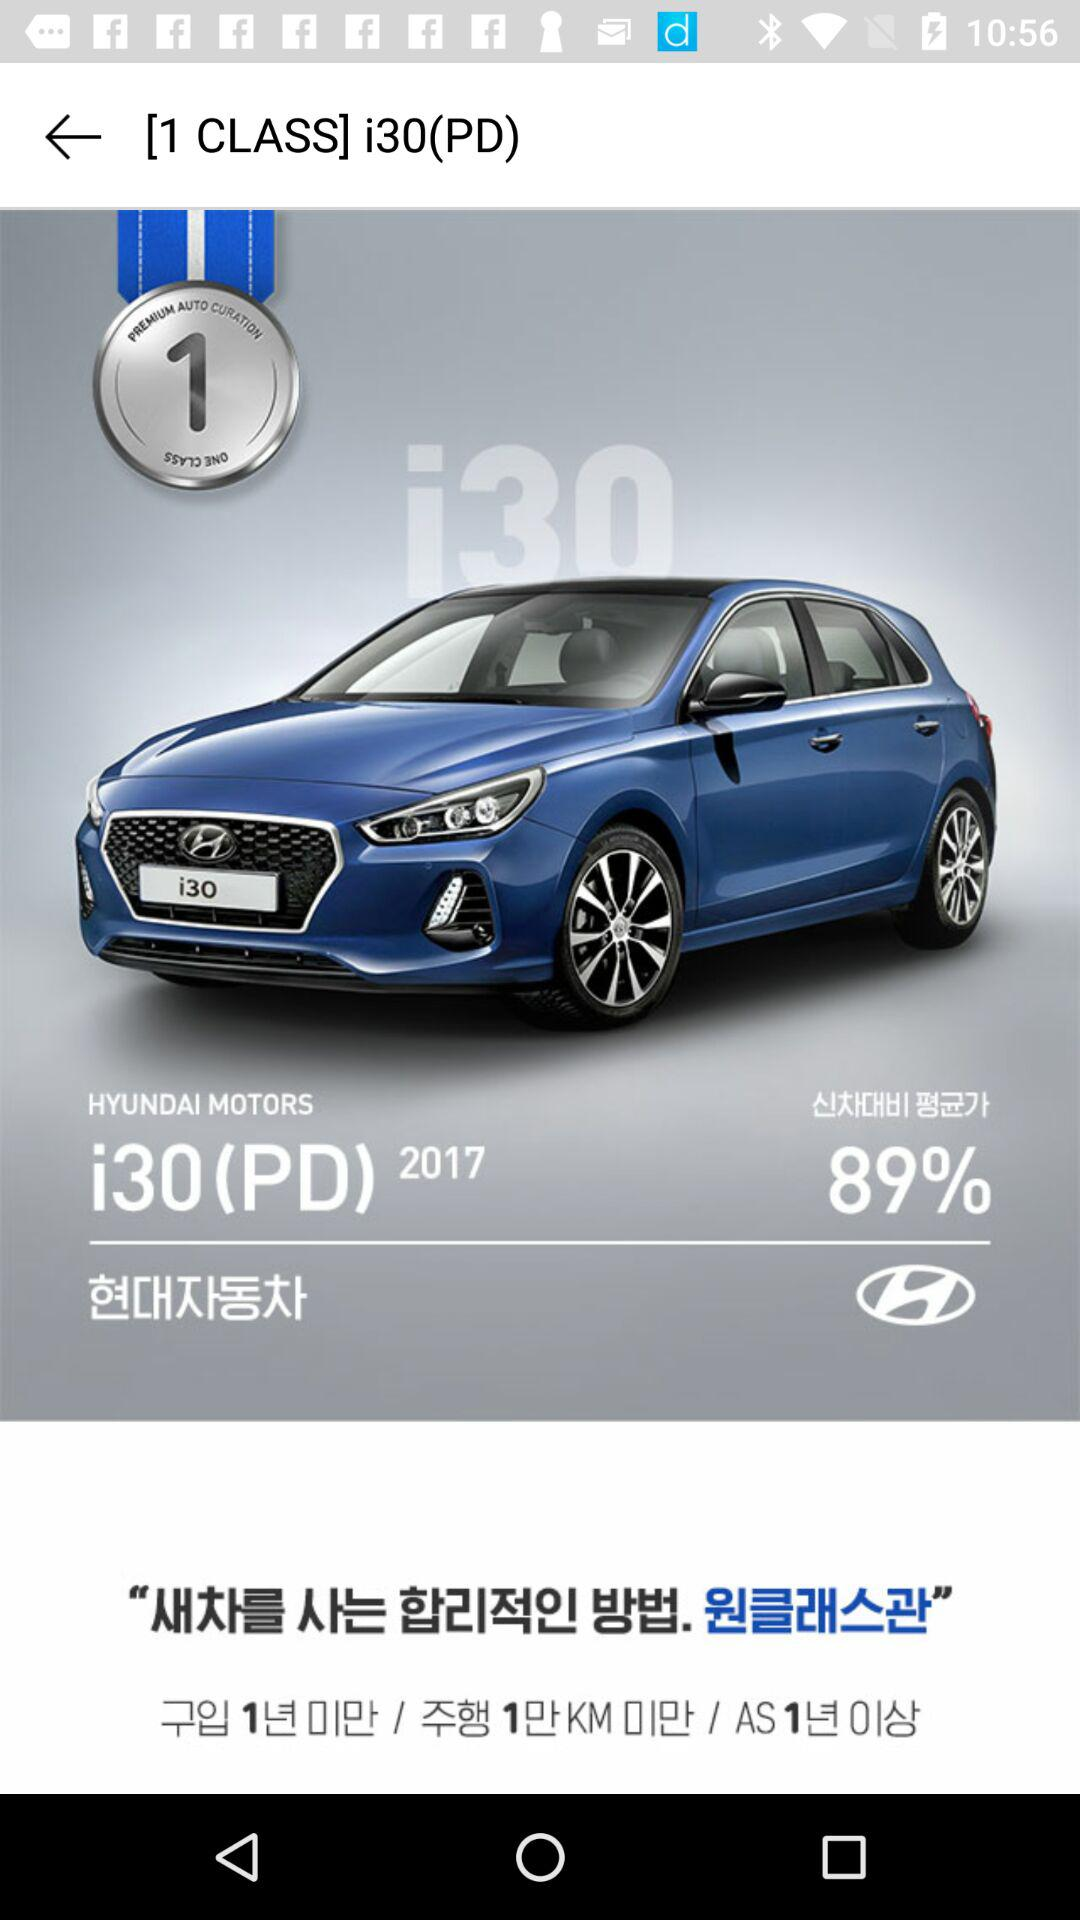What percentage off the original price is this vehicle?
Answer the question using a single word or phrase. 89% 